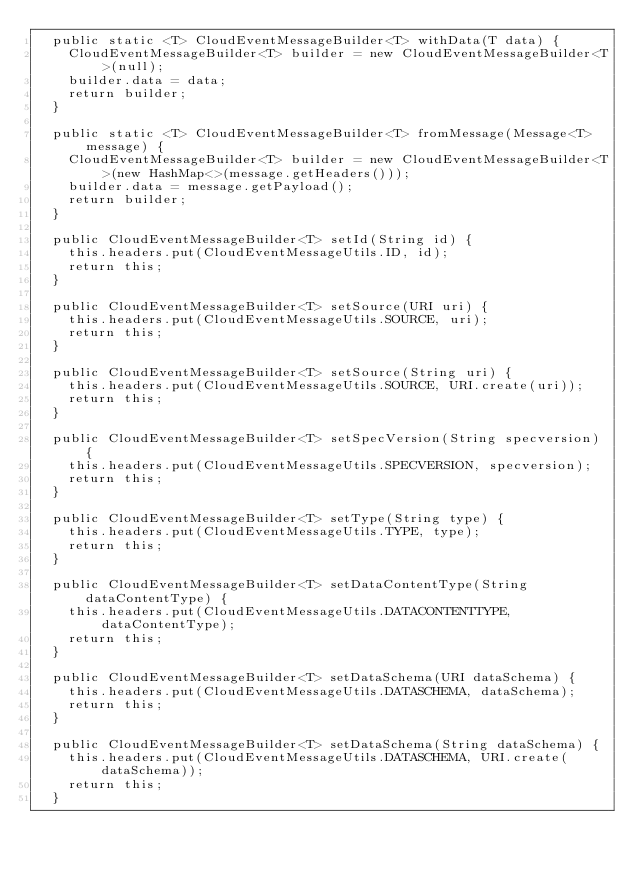<code> <loc_0><loc_0><loc_500><loc_500><_Java_>	public static <T> CloudEventMessageBuilder<T> withData(T data) {
		CloudEventMessageBuilder<T> builder = new CloudEventMessageBuilder<T>(null);
		builder.data = data;
		return builder;
	}

	public static <T> CloudEventMessageBuilder<T> fromMessage(Message<T> message) {
		CloudEventMessageBuilder<T> builder = new CloudEventMessageBuilder<T>(new HashMap<>(message.getHeaders()));
		builder.data = message.getPayload();
		return builder;
	}

	public CloudEventMessageBuilder<T> setId(String id) {
		this.headers.put(CloudEventMessageUtils.ID, id);
		return this;
	}

	public CloudEventMessageBuilder<T> setSource(URI uri) {
		this.headers.put(CloudEventMessageUtils.SOURCE, uri);
		return this;
	}

	public CloudEventMessageBuilder<T> setSource(String uri) {
		this.headers.put(CloudEventMessageUtils.SOURCE, URI.create(uri));
		return this;
	}

	public CloudEventMessageBuilder<T> setSpecVersion(String specversion) {
		this.headers.put(CloudEventMessageUtils.SPECVERSION, specversion);
		return this;
	}

	public CloudEventMessageBuilder<T> setType(String type) {
		this.headers.put(CloudEventMessageUtils.TYPE, type);
		return this;
	}

	public CloudEventMessageBuilder<T> setDataContentType(String dataContentType) {
		this.headers.put(CloudEventMessageUtils.DATACONTENTTYPE, dataContentType);
		return this;
	}

	public CloudEventMessageBuilder<T> setDataSchema(URI dataSchema) {
		this.headers.put(CloudEventMessageUtils.DATASCHEMA, dataSchema);
		return this;
	}

	public CloudEventMessageBuilder<T> setDataSchema(String dataSchema) {
		this.headers.put(CloudEventMessageUtils.DATASCHEMA, URI.create(dataSchema));
		return this;
	}
</code> 